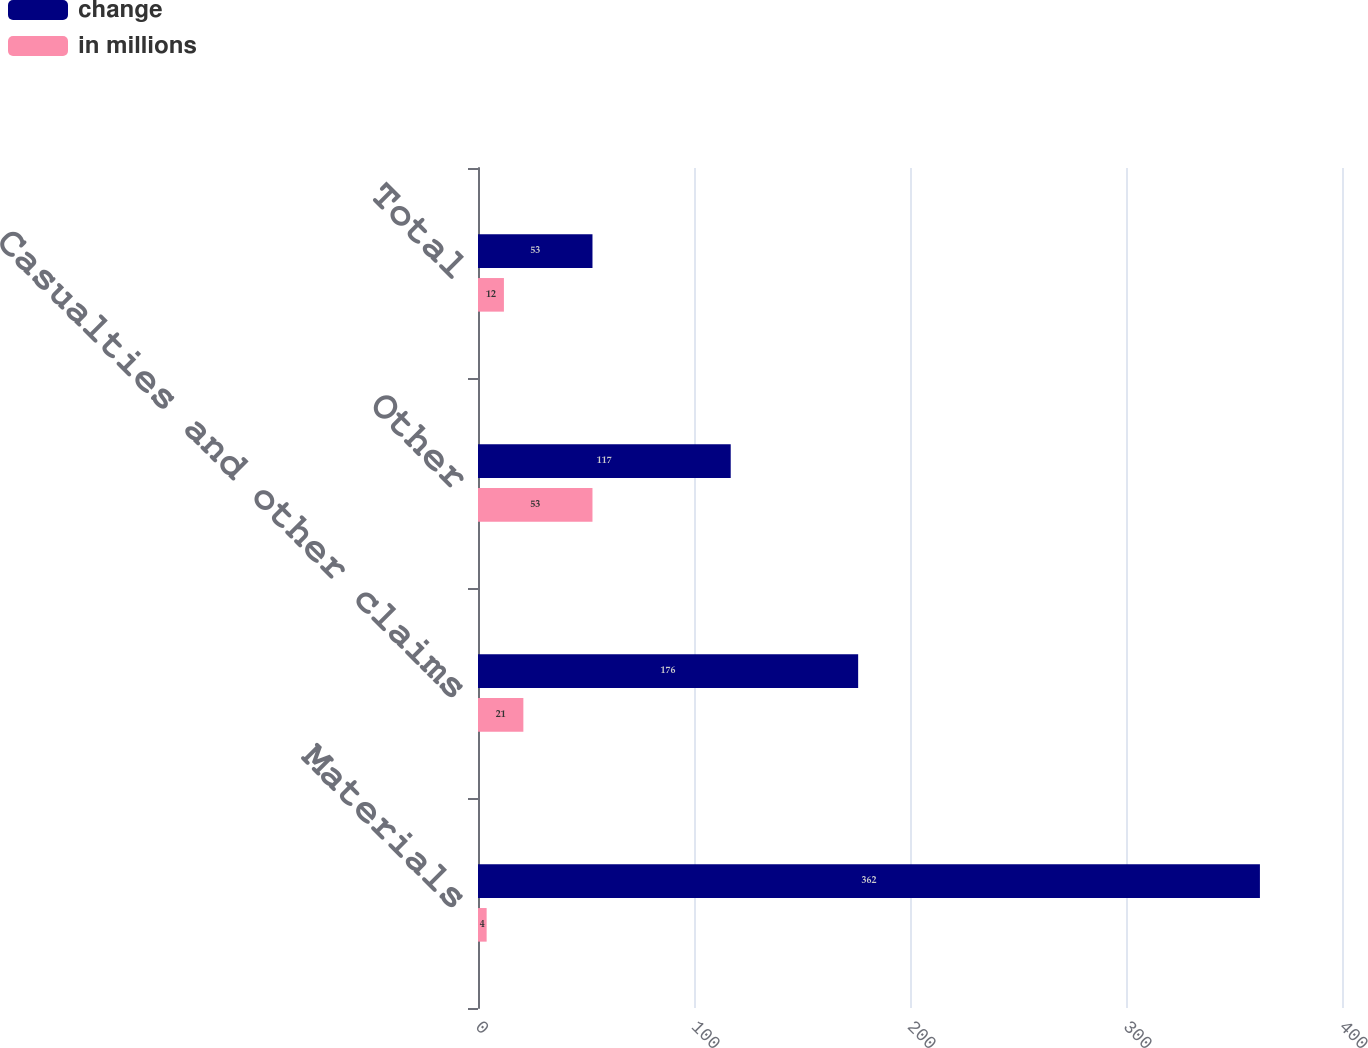<chart> <loc_0><loc_0><loc_500><loc_500><stacked_bar_chart><ecel><fcel>Materials<fcel>Casualties and other claims<fcel>Other<fcel>Total<nl><fcel>change<fcel>362<fcel>176<fcel>117<fcel>53<nl><fcel>in millions<fcel>4<fcel>21<fcel>53<fcel>12<nl></chart> 